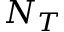<formula> <loc_0><loc_0><loc_500><loc_500>N _ { T }</formula> 